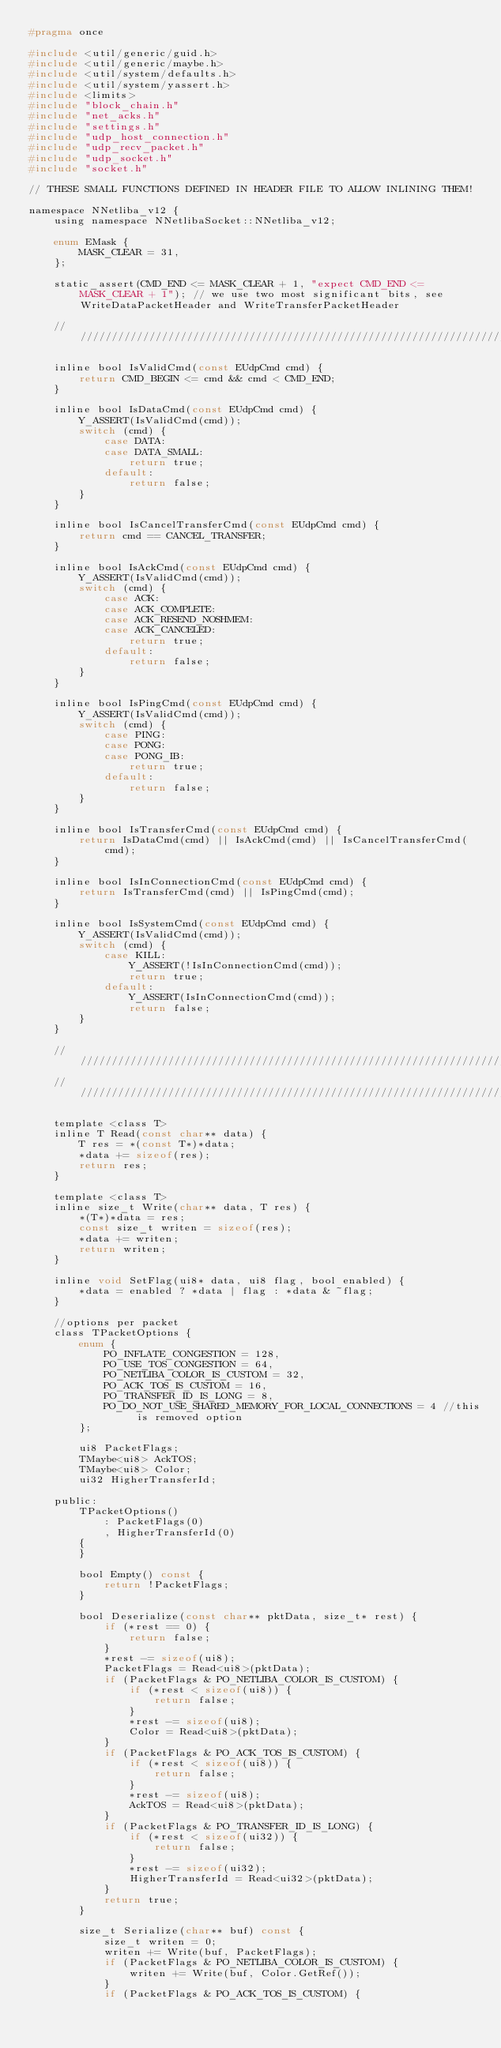<code> <loc_0><loc_0><loc_500><loc_500><_C_>#pragma once

#include <util/generic/guid.h>
#include <util/generic/maybe.h>
#include <util/system/defaults.h>
#include <util/system/yassert.h>
#include <limits>
#include "block_chain.h"
#include "net_acks.h"
#include "settings.h"
#include "udp_host_connection.h"
#include "udp_recv_packet.h"
#include "udp_socket.h"
#include "socket.h"

// THESE SMALL FUNCTIONS DEFINED IN HEADER FILE TO ALLOW INLINING THEM!

namespace NNetliba_v12 {
    using namespace NNetlibaSocket::NNetliba_v12;

    enum EMask {
        MASK_CLEAR = 31,
    };

    static_assert(CMD_END <= MASK_CLEAR + 1, "expect CMD_END <= MASK_CLEAR + 1"); // we use two most significant bits, see WriteDataPacketHeader and WriteTransferPacketHeader

    ///////////////////////////////////////////////////////////////////////////////

    inline bool IsValidCmd(const EUdpCmd cmd) {
        return CMD_BEGIN <= cmd && cmd < CMD_END;
    }

    inline bool IsDataCmd(const EUdpCmd cmd) {
        Y_ASSERT(IsValidCmd(cmd));
        switch (cmd) {
            case DATA:
            case DATA_SMALL:
                return true;
            default:
                return false;
        }
    }

    inline bool IsCancelTransferCmd(const EUdpCmd cmd) {
        return cmd == CANCEL_TRANSFER;
    }

    inline bool IsAckCmd(const EUdpCmd cmd) {
        Y_ASSERT(IsValidCmd(cmd));
        switch (cmd) {
            case ACK:
            case ACK_COMPLETE:
            case ACK_RESEND_NOSHMEM:
            case ACK_CANCELED:
                return true;
            default:
                return false;
        }
    }

    inline bool IsPingCmd(const EUdpCmd cmd) {
        Y_ASSERT(IsValidCmd(cmd));
        switch (cmd) {
            case PING:
            case PONG:
            case PONG_IB:
                return true;
            default:
                return false;
        }
    }

    inline bool IsTransferCmd(const EUdpCmd cmd) {
        return IsDataCmd(cmd) || IsAckCmd(cmd) || IsCancelTransferCmd(cmd);
    }

    inline bool IsInConnectionCmd(const EUdpCmd cmd) {
        return IsTransferCmd(cmd) || IsPingCmd(cmd);
    }

    inline bool IsSystemCmd(const EUdpCmd cmd) {
        Y_ASSERT(IsValidCmd(cmd));
        switch (cmd) {
            case KILL:
                Y_ASSERT(!IsInConnectionCmd(cmd));
                return true;
            default:
                Y_ASSERT(IsInConnectionCmd(cmd));
                return false;
        }
    }

    ///////////////////////////////////////////////////////////////////////////////
    ///////////////////////////////////////////////////////////////////////////////

    template <class T>
    inline T Read(const char** data) {
        T res = *(const T*)*data;
        *data += sizeof(res);
        return res;
    }

    template <class T>
    inline size_t Write(char** data, T res) {
        *(T*)*data = res;
        const size_t writen = sizeof(res);
        *data += writen;
        return writen;
    }

    inline void SetFlag(ui8* data, ui8 flag, bool enabled) {
        *data = enabled ? *data | flag : *data & ~flag;
    }

    //options per packet
    class TPacketOptions {
        enum {
            PO_INFLATE_CONGESTION = 128,
            PO_USE_TOS_CONGESTION = 64,
            PO_NETLIBA_COLOR_IS_CUSTOM = 32,
            PO_ACK_TOS_IS_CUSTOM = 16,
            PO_TRANSFER_ID_IS_LONG = 8,
            PO_DO_NOT_USE_SHARED_MEMORY_FOR_LOCAL_CONNECTIONS = 4 //this is removed option
        };

        ui8 PacketFlags;
        TMaybe<ui8> AckTOS;
        TMaybe<ui8> Color;
        ui32 HigherTransferId;

    public:
        TPacketOptions()
            : PacketFlags(0)
            , HigherTransferId(0)
        {
        }

        bool Empty() const {
            return !PacketFlags;
        }

        bool Deserialize(const char** pktData, size_t* rest) {
            if (*rest == 0) {
                return false;
            }
            *rest -= sizeof(ui8);
            PacketFlags = Read<ui8>(pktData);
            if (PacketFlags & PO_NETLIBA_COLOR_IS_CUSTOM) {
                if (*rest < sizeof(ui8)) {
                    return false;
                }
                *rest -= sizeof(ui8);
                Color = Read<ui8>(pktData);
            }
            if (PacketFlags & PO_ACK_TOS_IS_CUSTOM) {
                if (*rest < sizeof(ui8)) {
                    return false;
                }
                *rest -= sizeof(ui8);
                AckTOS = Read<ui8>(pktData);
            }
            if (PacketFlags & PO_TRANSFER_ID_IS_LONG) {
                if (*rest < sizeof(ui32)) {
                    return false;
                }
                *rest -= sizeof(ui32);
                HigherTransferId = Read<ui32>(pktData);
            }
            return true;
        }

        size_t Serialize(char** buf) const {
            size_t writen = 0;
            writen += Write(buf, PacketFlags);
            if (PacketFlags & PO_NETLIBA_COLOR_IS_CUSTOM) {
                writen += Write(buf, Color.GetRef());
            }
            if (PacketFlags & PO_ACK_TOS_IS_CUSTOM) {</code> 